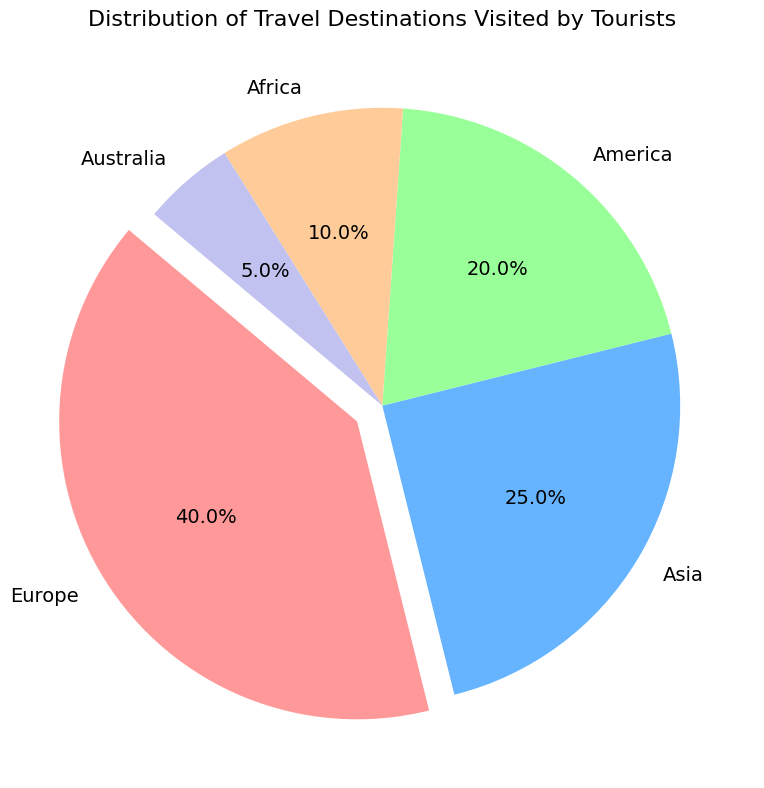Which continent has the highest percentage of tourists? By looking at the pie chart, the largest slice represents the continent with the highest percentage. Europe has the largest slice.
Answer: Europe Which continent has the smallest representation in tourists' visits? The smallest slice in the pie chart corresponds to the continent with the lowest percentage. Australia has the smallest slice.
Answer: Australia What is the combined percentage of tourists who visit Europe and Asia? Sum the percentages of Europe and Asia from the chart. Europe is 40% and Asia is 25%. 40% + 25% = 65%
Answer: 65% Which is more popular among tourists: Africa or America? Compare the sizes of the slices or the percentages. America has a slice of 20%, while Africa has 10%. America's slice is larger.
Answer: America How much more popular is Europe compared to Australia in terms of percentage? Subtract the percentage of Australia from the percentage of Europe. Europe is 40% and Australia is 5%. 40% - 5% = 35%
Answer: 35% What is the percentage difference between Asia and Africa? Subtract Africa's percentage from Asia's percentage. Asia is 25% and Africa is 10%. 25% - 10% = 15%
Answer: 15% If you combine the percentages of Africa, America, and Australia, do they collectively surpass the percentage of Europe? Add the percentages of Africa, America, and Australia: 10% + 20% + 5% = 35%. Europe is 40%. 35% is less than 40%.
Answer: No Which slice in the pie chart is highlighted (exploded) for emphasis? Observe the pie chart for the exploded (highlighted) slice. The slice representing Europe is exploded for emphasis.
Answer: Europe Which continents represent less than a quarter of the tourism visits individually? Compare each percentage with 25%. America (20%), Africa (10%), and Australia (5%) are all less than 25%.
Answer: America, Africa, Australia Is the percentage of tourists visiting Africa greater or lesser than half the percentage visiting Europe? Half of Europe's percentage is 40% / 2 = 20%. Africa's percentage is 10%. 10% is less than 20%.
Answer: Lesser 